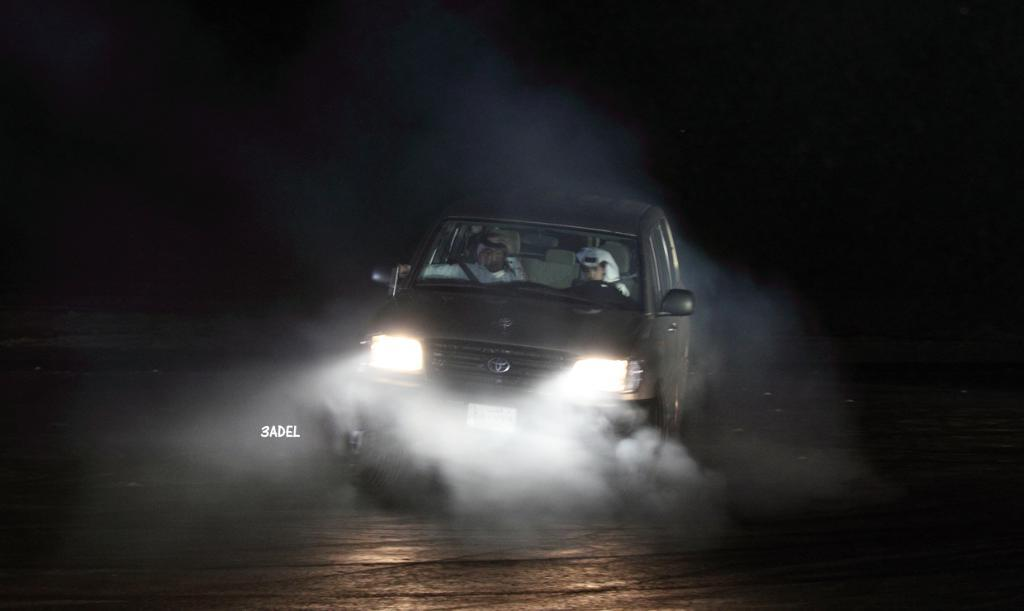What is the main subject of the image? The main subject of the image is a car. What is the car doing in the image? The car is moving on the road in the image. How many people are in the car? There are two people in the car. What can be seen in the background of the image? The background of the image is black. What is visible at the bottom of the image? There is a road visible at the bottom of the image. What is the profit of the car in the image? There is no mention of profit in the image, as it is focused on the car's movement and the people inside it. 